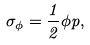Convert formula to latex. <formula><loc_0><loc_0><loc_500><loc_500>\sigma _ { \phi } = \frac { 1 } { 2 } \phi p ,</formula> 